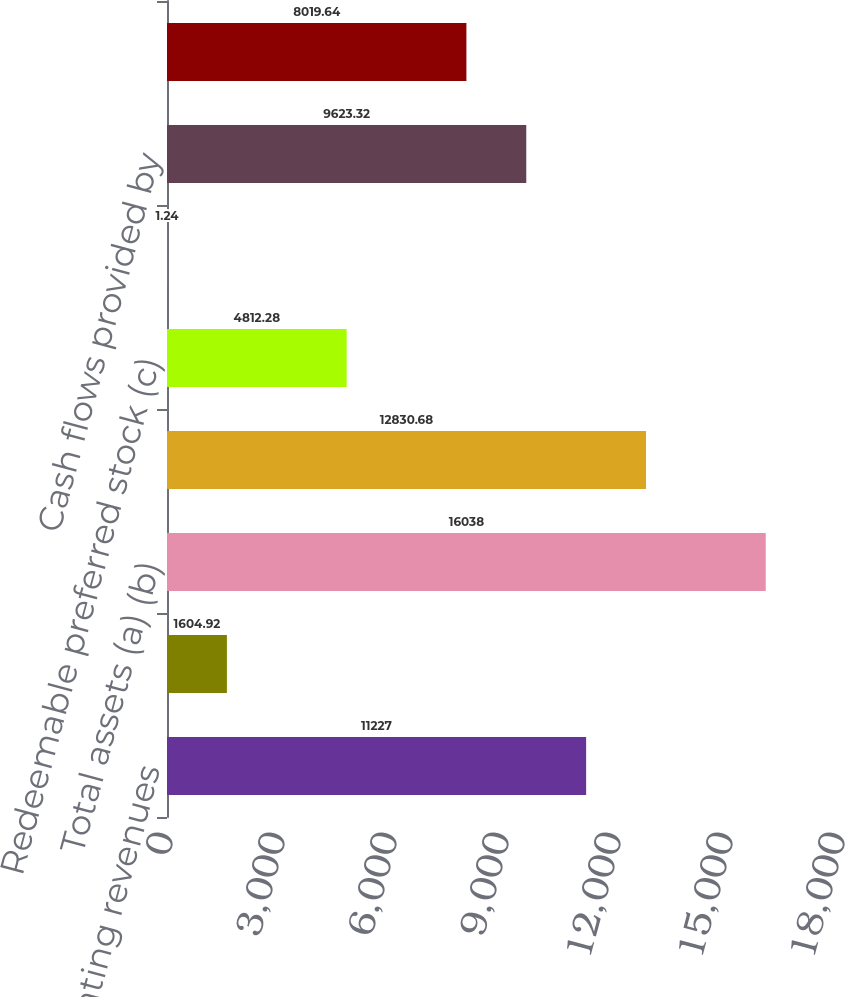Convert chart. <chart><loc_0><loc_0><loc_500><loc_500><bar_chart><fcel>Operating revenues<fcel>Income from continuing<fcel>Total assets (a) (b)<fcel>Short-term and long-term debt<fcel>Redeemable preferred stock (c)<fcel>Aggregate dividends declared<fcel>Cash flows provided by<fcel>Capital expenditures included<nl><fcel>11227<fcel>1604.92<fcel>16038<fcel>12830.7<fcel>4812.28<fcel>1.24<fcel>9623.32<fcel>8019.64<nl></chart> 